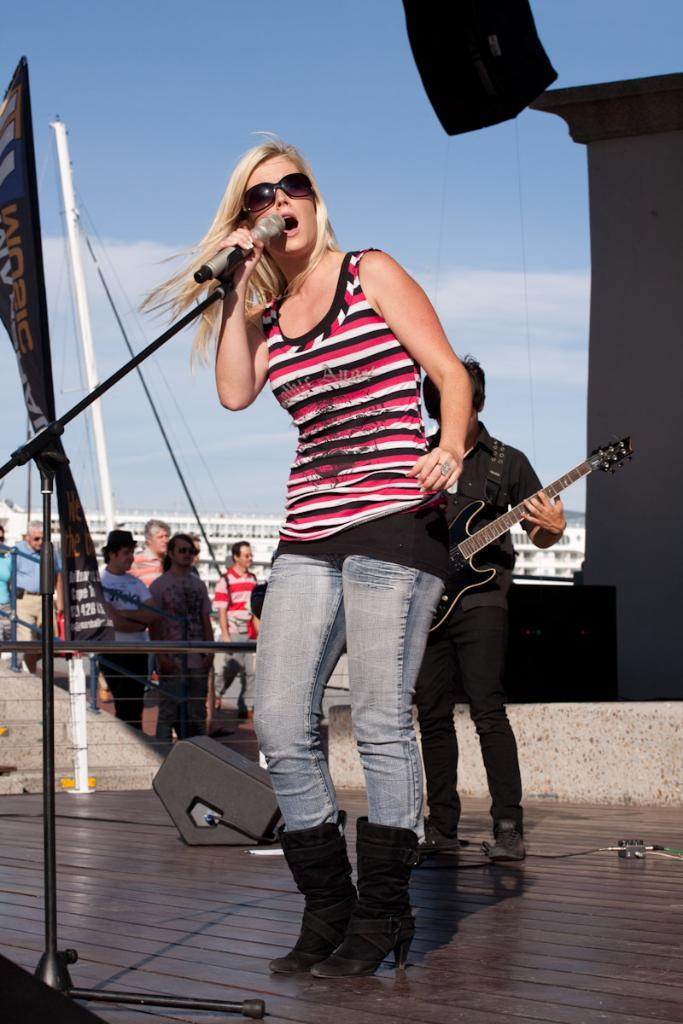Who is the main subject in the image? There is a woman in the image. What is the woman holding in the image? The woman is holding a microphone. Can you describe the person in the background of the image? The person in the background is holding a guitar. How many additional people are visible in the image? There are additional people visible in the image, but the exact number is not specified. What letters are being discussed in the meeting in the image? There is no meeting present in the image, and therefore no discussion of letters can be observed. 